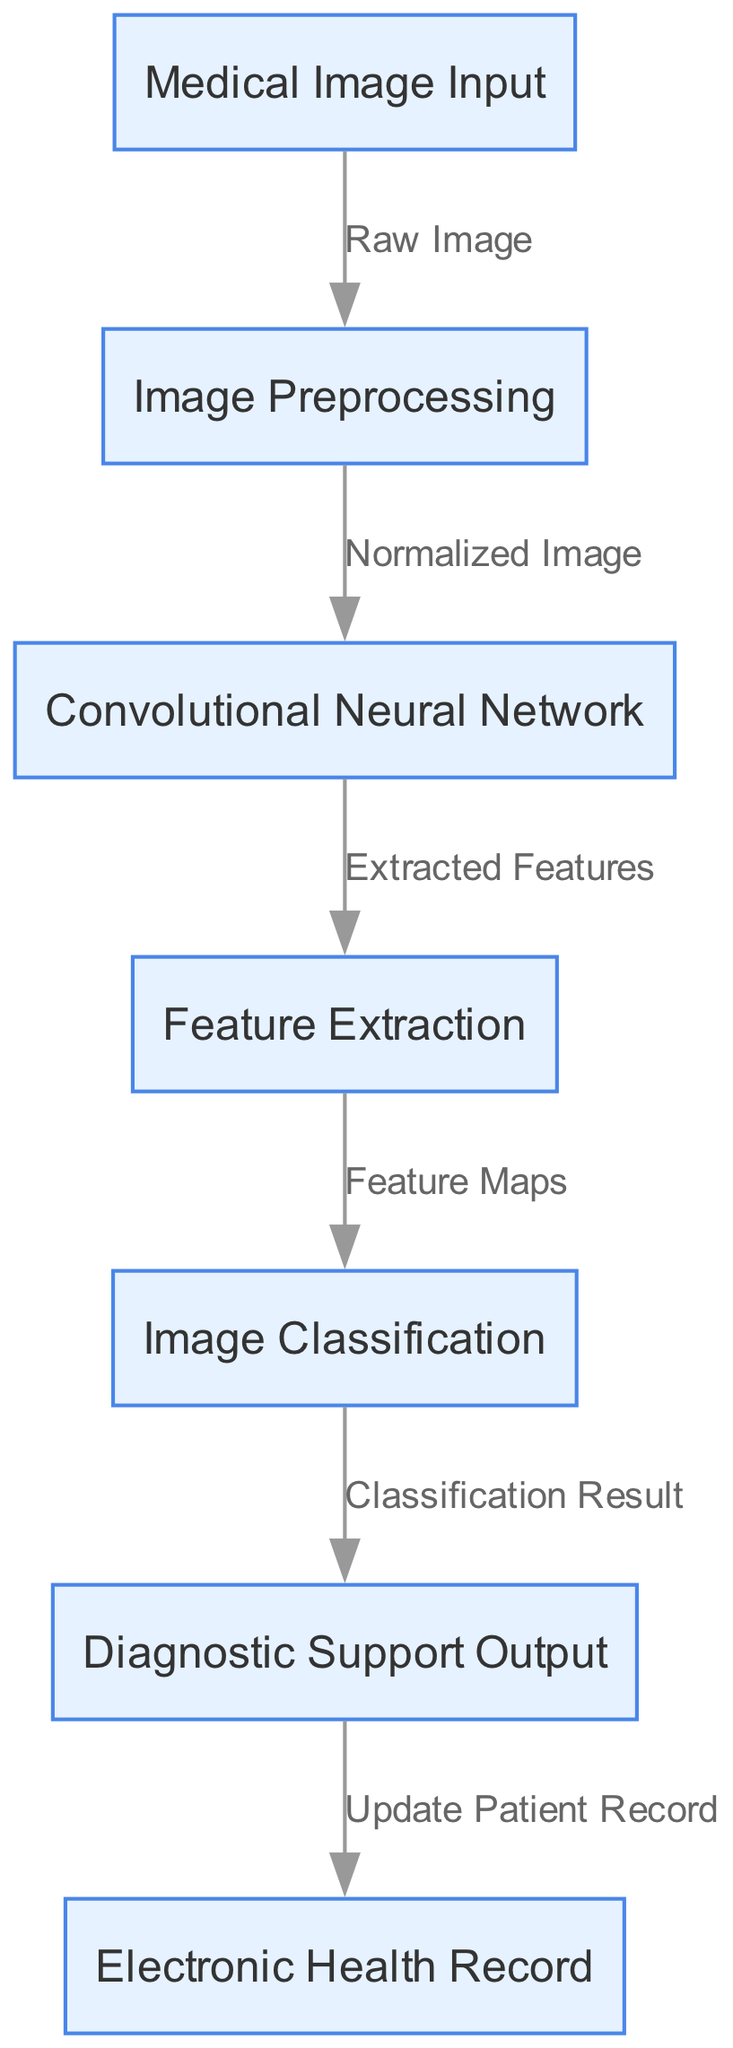What's the first node in the diagram? The diagram starts with the node labeled "Medical Image Input," which is the first step in the processing flow.
Answer: Medical Image Input How many nodes are present in the diagram? There are a total of seven nodes listed in the diagram, each representing a distinct step in the neural network architecture.
Answer: Seven What label is associated with the last node? The last node, which is the final output of the diagram, is labeled "Diagnostic Support Output."
Answer: Diagnostic Support Output What does the 'preprocess' node output? The 'preprocess' node outputs a "Normalized Image," which is essential for the subsequent processing in the neural network.
Answer: Normalized Image Which nodes are directly connected to 'classify'? The 'classify' node is directly connected to the 'feature' node and outputs to the 'output' node, indicating the classification process is based on extracted features from the previous step.
Answer: Feature Extraction, Diagnostic Support Output What is the connection between 'output' and 'ehr'? The 'output' node provides classification results that are used to "Update Patient Record" in the 'ehr' node, which indicates the integration of diagnostic support with electronic health records.
Answer: Update Patient Record Which process follows 'feature extraction'? After the 'feature extraction' process, the next step is 'Image Classification' to determine the type of diagnosis based on the features extracted.
Answer: Image Classification How does the 'cnn' node contribute to the process? The 'cnn' node extracts features from the normalized image, enabling the subsequent classification to be more accurate based on learned patterns from the image data.
Answer: Extracted Features What is the flow of data starting from 'input'? The flow starts with the 'Medical Image Input,' which goes to 'Image Preprocessing,' then to 'Convolutional Neural Network,' followed by 'Feature Extraction,' then 'Image Classification,' and finally leads to 'Diagnostic Support Output.'
Answer: Medical Image Input to Diagnostic Support Output 